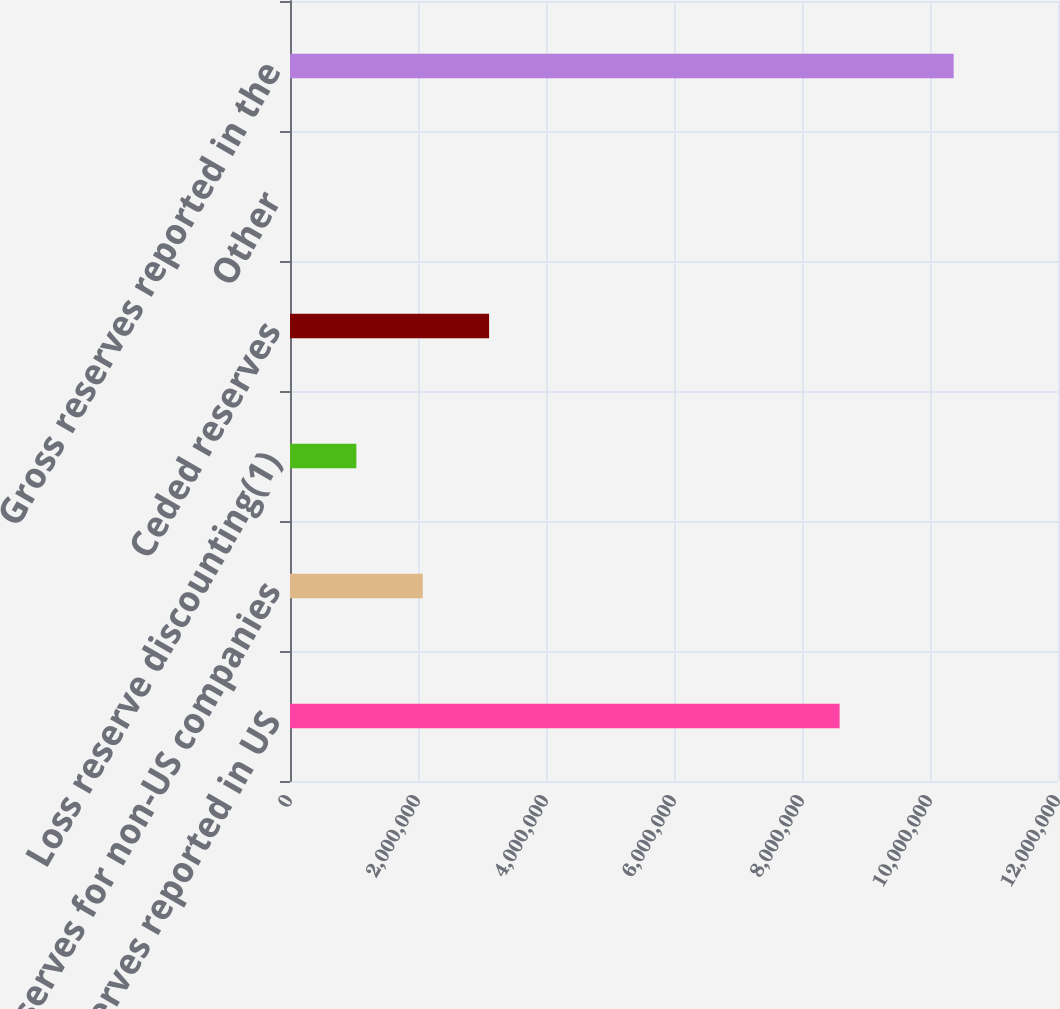<chart> <loc_0><loc_0><loc_500><loc_500><bar_chart><fcel>Net reserves reported in US<fcel>Reserves for non-US companies<fcel>Loss reserve discounting(1)<fcel>Ceded reserves<fcel>Other<fcel>Gross reserves reported in the<nl><fcel>8.58748e+06<fcel>2.07398e+06<fcel>1.03702e+06<fcel>3.11095e+06<fcel>55<fcel>1.03697e+07<nl></chart> 